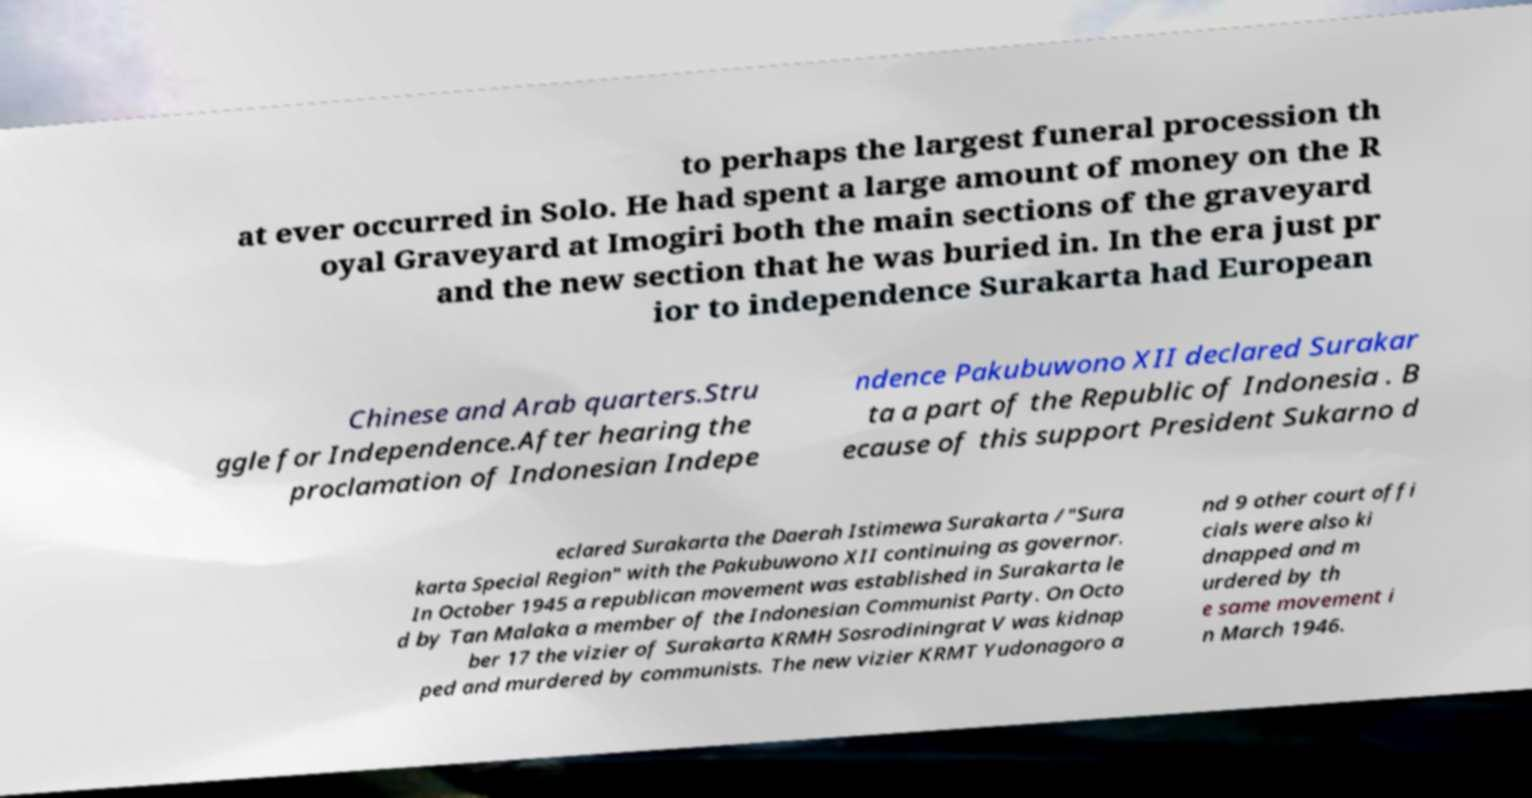For documentation purposes, I need the text within this image transcribed. Could you provide that? to perhaps the largest funeral procession th at ever occurred in Solo. He had spent a large amount of money on the R oyal Graveyard at Imogiri both the main sections of the graveyard and the new section that he was buried in. In the era just pr ior to independence Surakarta had European Chinese and Arab quarters.Stru ggle for Independence.After hearing the proclamation of Indonesian Indepe ndence Pakubuwono XII declared Surakar ta a part of the Republic of Indonesia . B ecause of this support President Sukarno d eclared Surakarta the Daerah Istimewa Surakarta /"Sura karta Special Region" with the Pakubuwono XII continuing as governor. In October 1945 a republican movement was established in Surakarta le d by Tan Malaka a member of the Indonesian Communist Party. On Octo ber 17 the vizier of Surakarta KRMH Sosrodiningrat V was kidnap ped and murdered by communists. The new vizier KRMT Yudonagoro a nd 9 other court offi cials were also ki dnapped and m urdered by th e same movement i n March 1946. 